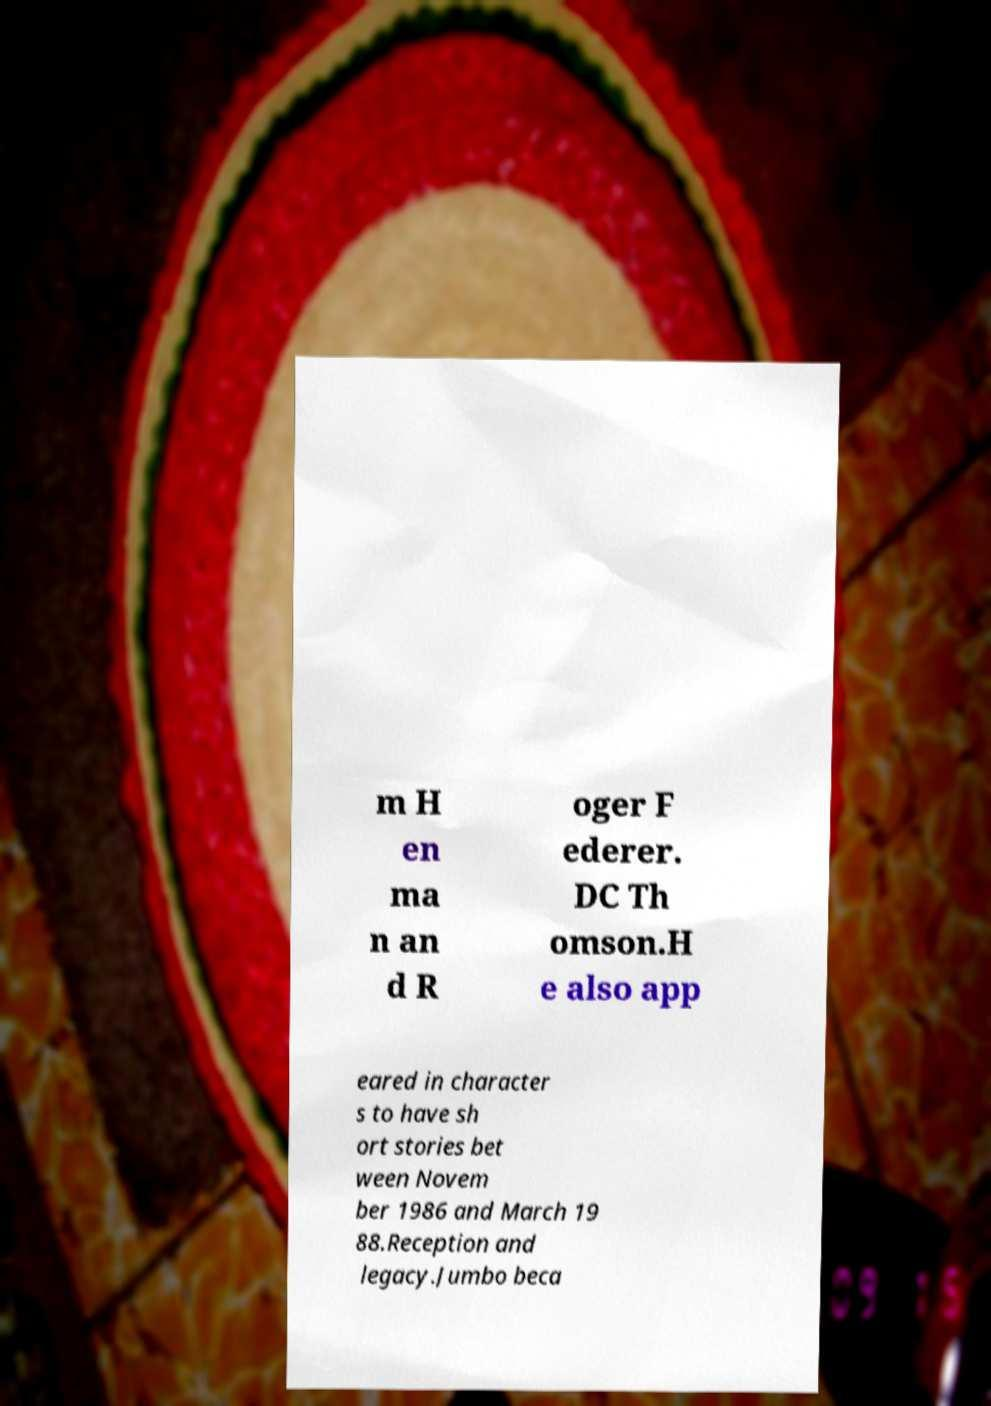Could you assist in decoding the text presented in this image and type it out clearly? m H en ma n an d R oger F ederer. DC Th omson.H e also app eared in character s to have sh ort stories bet ween Novem ber 1986 and March 19 88.Reception and legacy.Jumbo beca 